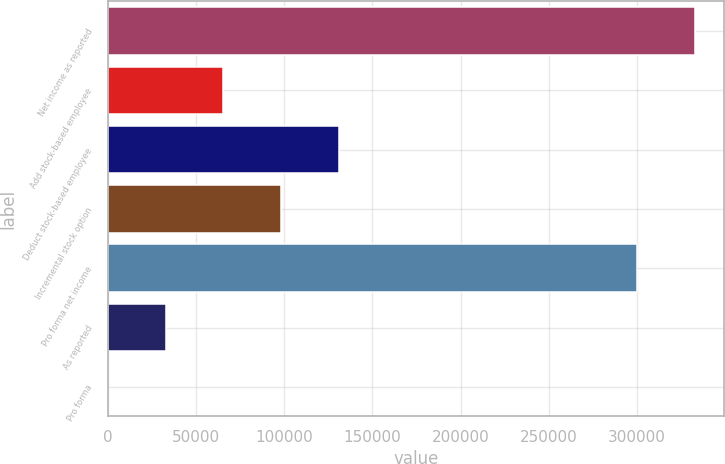Convert chart. <chart><loc_0><loc_0><loc_500><loc_500><bar_chart><fcel>Net income as reported<fcel>Add stock-based employee<fcel>Deduct stock-based employee<fcel>Incremental stock option<fcel>Pro forma net income<fcel>As reported<fcel>Pro forma<nl><fcel>332729<fcel>65601.4<fcel>131201<fcel>98400.9<fcel>299929<fcel>32801.8<fcel>2.2<nl></chart> 